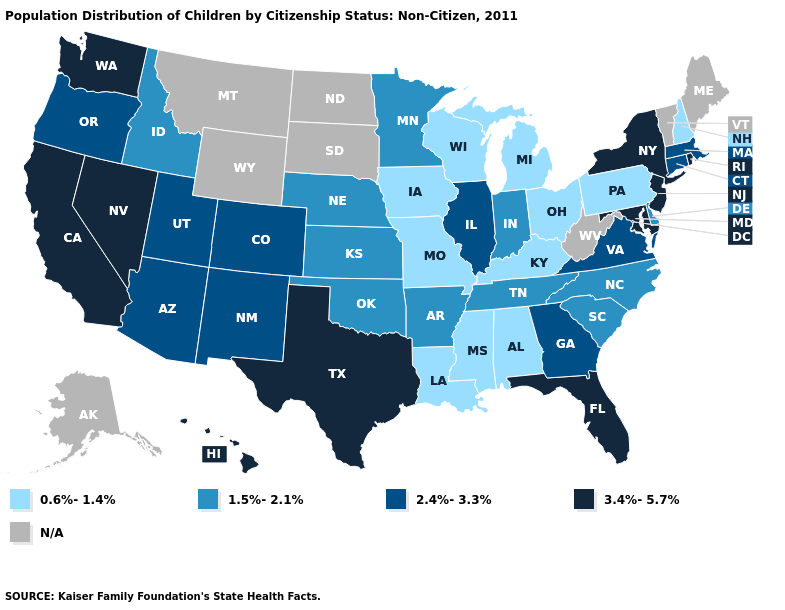What is the value of Kansas?
Be succinct. 1.5%-2.1%. Which states have the lowest value in the West?
Give a very brief answer. Idaho. What is the value of Rhode Island?
Be succinct. 3.4%-5.7%. Does the first symbol in the legend represent the smallest category?
Keep it brief. Yes. Is the legend a continuous bar?
Answer briefly. No. What is the value of Minnesota?
Concise answer only. 1.5%-2.1%. Does the first symbol in the legend represent the smallest category?
Write a very short answer. Yes. Does the first symbol in the legend represent the smallest category?
Answer briefly. Yes. What is the lowest value in the USA?
Concise answer only. 0.6%-1.4%. Among the states that border New Jersey , which have the lowest value?
Give a very brief answer. Pennsylvania. Does Indiana have the lowest value in the MidWest?
Give a very brief answer. No. Among the states that border California , does Nevada have the highest value?
Keep it brief. Yes. What is the value of Maryland?
Be succinct. 3.4%-5.7%. What is the highest value in the West ?
Answer briefly. 3.4%-5.7%. Which states have the lowest value in the USA?
Be succinct. Alabama, Iowa, Kentucky, Louisiana, Michigan, Mississippi, Missouri, New Hampshire, Ohio, Pennsylvania, Wisconsin. 